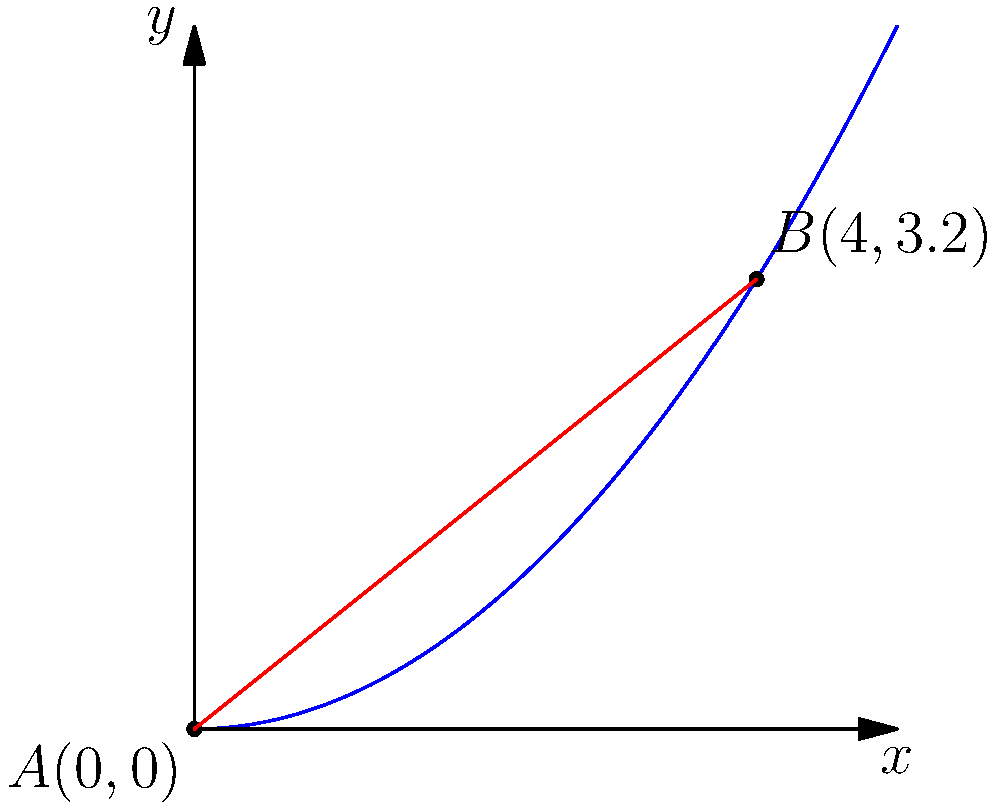At the Osaka Country Club, you're faced with a challenging fairway that curves upward. The fairway can be modeled by the function $y = 0.2x^2$, where $x$ and $y$ are measured in tens of meters. You need to drive your golf cart from point $A(0,0)$ to point $B(4,3.2)$. What is the shortest distance between these two points, rounded to two decimal places? To find the shortest distance between two points on a curved surface, we can use the concept of a straight line in 3D space. Here's how to solve this problem:

1) The two points are $A(0,0)$ and $B(4,3.2)$.

2) The distance between two points $(x_1,y_1)$ and $(x_2,y_2)$ is given by the formula:

   $$d = \sqrt{(x_2-x_1)^2 + (y_2-y_1)^2}$$

3) Substituting our points:

   $$d = \sqrt{(4-0)^2 + (3.2-0)^2}$$

4) Simplify:

   $$d = \sqrt{16 + 10.24}$$

5) Calculate:

   $$d = \sqrt{26.24} \approx 5.1225$$

6) Rounding to two decimal places:

   $$d \approx 5.12$$

Therefore, the shortest distance between points $A$ and $B$ is approximately 5.12 tens of meters, or 51.2 meters.
Answer: 51.2 meters 